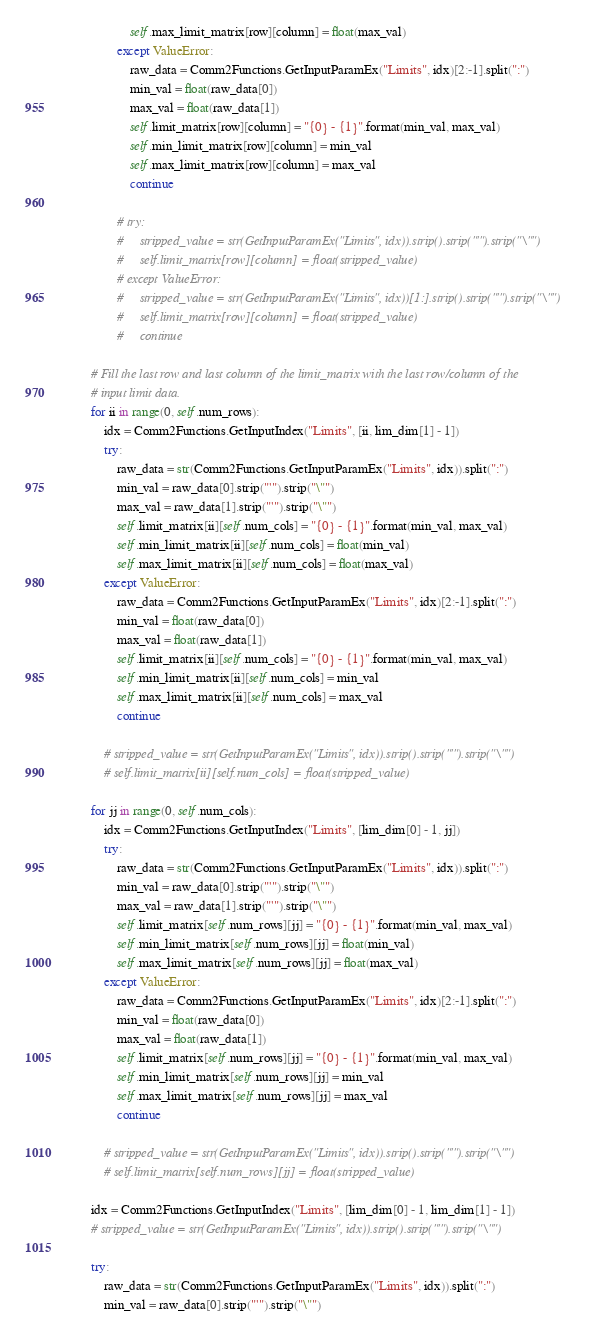Convert code to text. <code><loc_0><loc_0><loc_500><loc_500><_Python_>                    self.max_limit_matrix[row][column] = float(max_val)
                except ValueError:
                    raw_data = Comm2Functions.GetInputParamEx("Limits", idx)[2:-1].split(":")
                    min_val = float(raw_data[0])
                    max_val = float(raw_data[1])
                    self.limit_matrix[row][column] = "{0} - {1}".format(min_val, max_val)
                    self.min_limit_matrix[row][column] = min_val
                    self.max_limit_matrix[row][column] = max_val
                    continue

                # try:
                #     stripped_value = str(GetInputParamEx("Limits", idx)).strip().strip("'").strip("\"")
                #     self.limit_matrix[row][column] = float(stripped_value)
                # except ValueError:
                #     stripped_value = str(GetInputParamEx("Limits", idx))[1:].strip().strip("'").strip("\"")
                #     self.limit_matrix[row][column] = float(stripped_value)
                #     continue

        # Fill the last row and last column of the limit_matrix with the last row/column of the
        # input limit data.
        for ii in range(0, self.num_rows):
            idx = Comm2Functions.GetInputIndex("Limits", [ii, lim_dim[1] - 1])
            try:
                raw_data = str(Comm2Functions.GetInputParamEx("Limits", idx)).split(":")
                min_val = raw_data[0].strip("'").strip("\"")
                max_val = raw_data[1].strip("'").strip("\"")
                self.limit_matrix[ii][self.num_cols] = "{0} - {1}".format(min_val, max_val)
                self.min_limit_matrix[ii][self.num_cols] = float(min_val)
                self.max_limit_matrix[ii][self.num_cols] = float(max_val)
            except ValueError:
                raw_data = Comm2Functions.GetInputParamEx("Limits", idx)[2:-1].split(":")
                min_val = float(raw_data[0])
                max_val = float(raw_data[1])
                self.limit_matrix[ii][self.num_cols] = "{0} - {1}".format(min_val, max_val)
                self.min_limit_matrix[ii][self.num_cols] = min_val
                self.max_limit_matrix[ii][self.num_cols] = max_val
                continue

            # stripped_value = str(GetInputParamEx("Limits", idx)).strip().strip("'").strip("\"")
            # self.limit_matrix[ii][self.num_cols] = float(stripped_value)

        for jj in range(0, self.num_cols):
            idx = Comm2Functions.GetInputIndex("Limits", [lim_dim[0] - 1, jj])
            try:
                raw_data = str(Comm2Functions.GetInputParamEx("Limits", idx)).split(":")
                min_val = raw_data[0].strip("'").strip("\"")
                max_val = raw_data[1].strip("'").strip("\"")
                self.limit_matrix[self.num_rows][jj] = "{0} - {1}".format(min_val, max_val)
                self.min_limit_matrix[self.num_rows][jj] = float(min_val)
                self.max_limit_matrix[self.num_rows][jj] = float(max_val)
            except ValueError:
                raw_data = Comm2Functions.GetInputParamEx("Limits", idx)[2:-1].split(":")
                min_val = float(raw_data[0])
                max_val = float(raw_data[1])
                self.limit_matrix[self.num_rows][jj] = "{0} - {1}".format(min_val, max_val)
                self.min_limit_matrix[self.num_rows][jj] = min_val
                self.max_limit_matrix[self.num_rows][jj] = max_val
                continue

            # stripped_value = str(GetInputParamEx("Limits", idx)).strip().strip("'").strip("\"")
            # self.limit_matrix[self.num_rows][jj] = float(stripped_value)

        idx = Comm2Functions.GetInputIndex("Limits", [lim_dim[0] - 1, lim_dim[1] - 1])
        # stripped_value = str(GetInputParamEx("Limits", idx)).strip().strip("'").strip("\"")

        try:
            raw_data = str(Comm2Functions.GetInputParamEx("Limits", idx)).split(":")
            min_val = raw_data[0].strip("'").strip("\"")</code> 